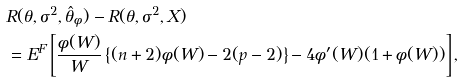Convert formula to latex. <formula><loc_0><loc_0><loc_500><loc_500>& R ( \theta , \sigma ^ { 2 } , \hat { \theta } _ { \phi } ) - R ( \theta , \sigma ^ { 2 } , X ) \\ & = E ^ { F } \left [ \frac { \phi ( W ) } { W } \left \{ ( n + 2 ) \phi ( W ) - 2 ( p - 2 ) \right \} - 4 \phi ^ { \prime } ( W ) ( 1 + \phi ( W ) ) \right ] ,</formula> 